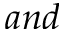<formula> <loc_0><loc_0><loc_500><loc_500>a n d</formula> 